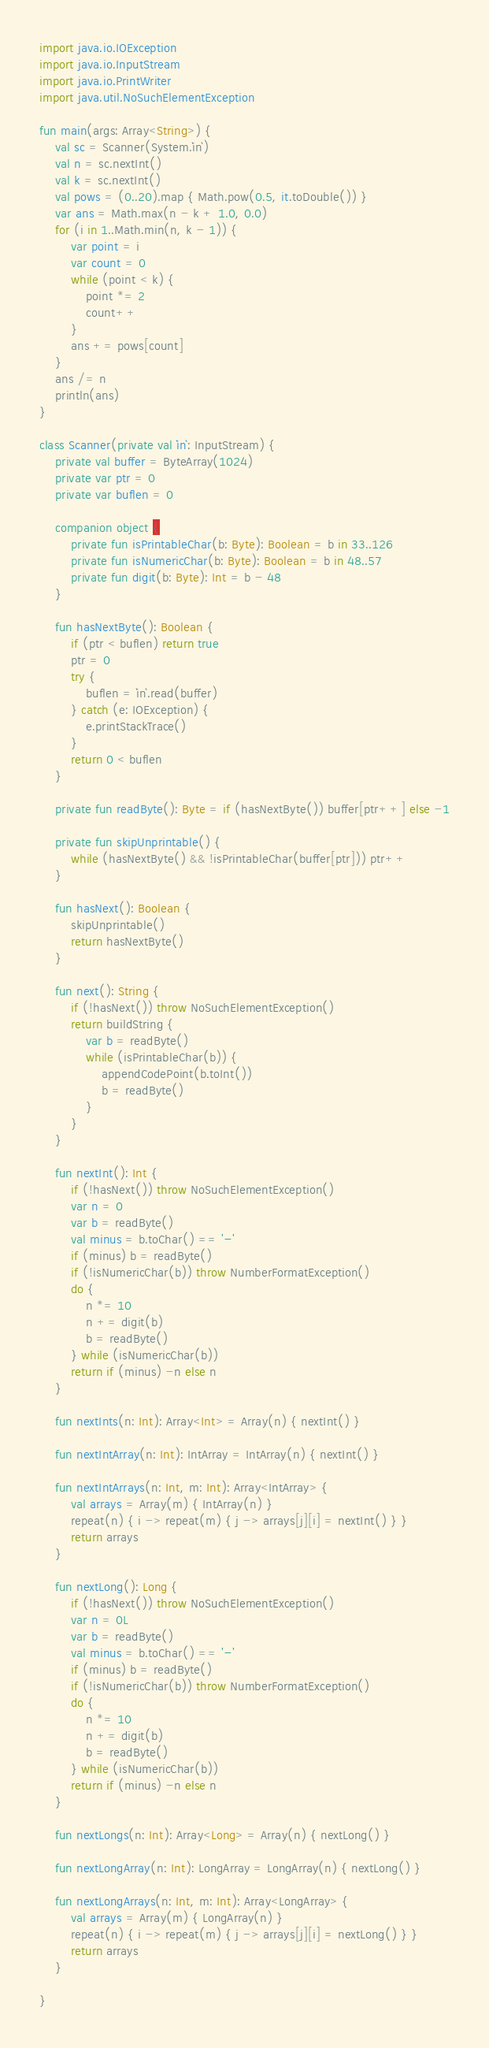<code> <loc_0><loc_0><loc_500><loc_500><_Kotlin_>import java.io.IOException
import java.io.InputStream
import java.io.PrintWriter
import java.util.NoSuchElementException

fun main(args: Array<String>) {
    val sc = Scanner(System.`in`)
    val n = sc.nextInt()
    val k = sc.nextInt()
    val pows = (0..20).map { Math.pow(0.5, it.toDouble()) }
    var ans = Math.max(n - k + 1.0, 0.0)
    for (i in 1..Math.min(n, k - 1)) {
        var point = i
        var count = 0
        while (point < k) {
            point *= 2
            count++
        }
        ans += pows[count]
    }
    ans /= n
    println(ans)
}

class Scanner(private val `in`: InputStream) {
    private val buffer = ByteArray(1024)
    private var ptr = 0
    private var buflen = 0

    companion object {
        private fun isPrintableChar(b: Byte): Boolean = b in 33..126
        private fun isNumericChar(b: Byte): Boolean = b in 48..57
        private fun digit(b: Byte): Int = b - 48
    }

    fun hasNextByte(): Boolean {
        if (ptr < buflen) return true
        ptr = 0
        try {
            buflen = `in`.read(buffer)
        } catch (e: IOException) {
            e.printStackTrace()
        }
        return 0 < buflen
    }

    private fun readByte(): Byte = if (hasNextByte()) buffer[ptr++] else -1

    private fun skipUnprintable() {
        while (hasNextByte() && !isPrintableChar(buffer[ptr])) ptr++
    }

    fun hasNext(): Boolean {
        skipUnprintable()
        return hasNextByte()
    }

    fun next(): String {
        if (!hasNext()) throw NoSuchElementException()
        return buildString {
            var b = readByte()
            while (isPrintableChar(b)) {
                appendCodePoint(b.toInt())
                b = readByte()
            }
        }
    }

    fun nextInt(): Int {
        if (!hasNext()) throw NoSuchElementException()
        var n = 0
        var b = readByte()
        val minus = b.toChar() == '-'
        if (minus) b = readByte()
        if (!isNumericChar(b)) throw NumberFormatException()
        do {
            n *= 10
            n += digit(b)
            b = readByte()
        } while (isNumericChar(b))
        return if (minus) -n else n
    }

    fun nextInts(n: Int): Array<Int> = Array(n) { nextInt() }

    fun nextIntArray(n: Int): IntArray = IntArray(n) { nextInt() }

    fun nextIntArrays(n: Int, m: Int): Array<IntArray> {
        val arrays = Array(m) { IntArray(n) }
        repeat(n) { i -> repeat(m) { j -> arrays[j][i] = nextInt() } }
        return arrays
    }

    fun nextLong(): Long {
        if (!hasNext()) throw NoSuchElementException()
        var n = 0L
        var b = readByte()
        val minus = b.toChar() == '-'
        if (minus) b = readByte()
        if (!isNumericChar(b)) throw NumberFormatException()
        do {
            n *= 10
            n += digit(b)
            b = readByte()
        } while (isNumericChar(b))
        return if (minus) -n else n
    }

    fun nextLongs(n: Int): Array<Long> = Array(n) { nextLong() }

    fun nextLongArray(n: Int): LongArray = LongArray(n) { nextLong() }

    fun nextLongArrays(n: Int, m: Int): Array<LongArray> {
        val arrays = Array(m) { LongArray(n) }
        repeat(n) { i -> repeat(m) { j -> arrays[j][i] = nextLong() } }
        return arrays
    }

}</code> 